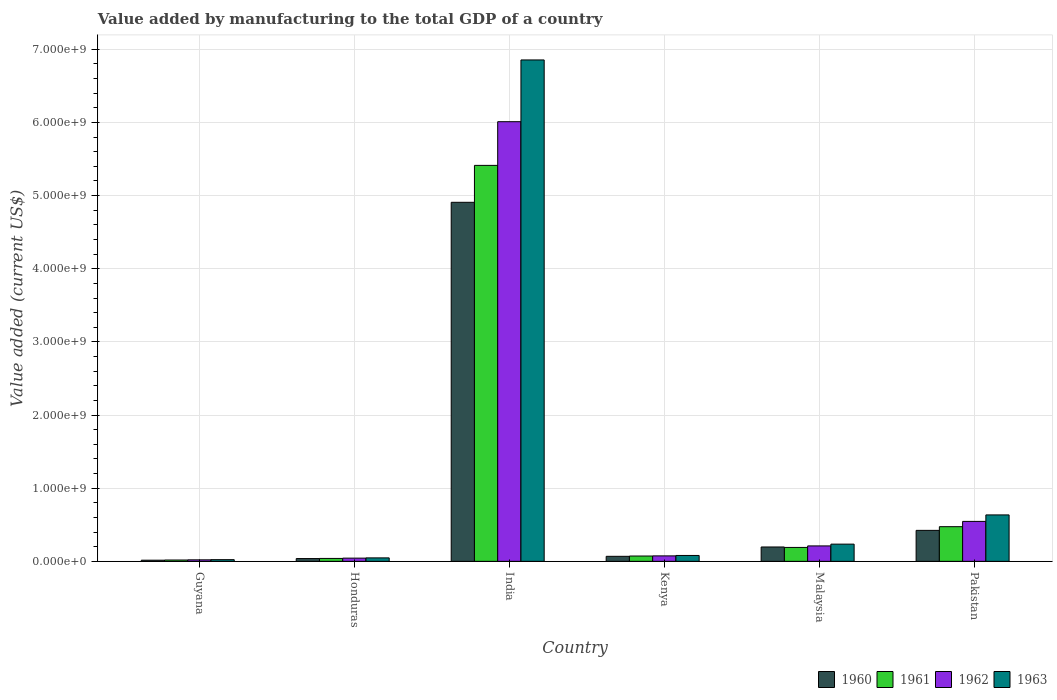How many groups of bars are there?
Offer a very short reply. 6. Are the number of bars per tick equal to the number of legend labels?
Make the answer very short. Yes. How many bars are there on the 1st tick from the right?
Your answer should be compact. 4. What is the label of the 1st group of bars from the left?
Make the answer very short. Guyana. In how many cases, is the number of bars for a given country not equal to the number of legend labels?
Provide a succinct answer. 0. What is the value added by manufacturing to the total GDP in 1960 in India?
Offer a terse response. 4.91e+09. Across all countries, what is the maximum value added by manufacturing to the total GDP in 1961?
Offer a very short reply. 5.41e+09. Across all countries, what is the minimum value added by manufacturing to the total GDP in 1963?
Offer a very short reply. 2.32e+07. In which country was the value added by manufacturing to the total GDP in 1961 minimum?
Your answer should be very brief. Guyana. What is the total value added by manufacturing to the total GDP in 1961 in the graph?
Your response must be concise. 6.21e+09. What is the difference between the value added by manufacturing to the total GDP in 1961 in Honduras and that in Pakistan?
Keep it short and to the point. -4.34e+08. What is the difference between the value added by manufacturing to the total GDP in 1961 in Kenya and the value added by manufacturing to the total GDP in 1960 in Guyana?
Provide a succinct answer. 5.70e+07. What is the average value added by manufacturing to the total GDP in 1963 per country?
Your answer should be very brief. 1.31e+09. What is the difference between the value added by manufacturing to the total GDP of/in 1963 and value added by manufacturing to the total GDP of/in 1961 in Kenya?
Offer a terse response. 7.70e+06. In how many countries, is the value added by manufacturing to the total GDP in 1961 greater than 4000000000 US$?
Provide a succinct answer. 1. What is the ratio of the value added by manufacturing to the total GDP in 1962 in India to that in Kenya?
Your response must be concise. 80.31. Is the value added by manufacturing to the total GDP in 1963 in Honduras less than that in Pakistan?
Ensure brevity in your answer.  Yes. Is the difference between the value added by manufacturing to the total GDP in 1963 in Guyana and Malaysia greater than the difference between the value added by manufacturing to the total GDP in 1961 in Guyana and Malaysia?
Make the answer very short. No. What is the difference between the highest and the second highest value added by manufacturing to the total GDP in 1960?
Offer a very short reply. 2.27e+08. What is the difference between the highest and the lowest value added by manufacturing to the total GDP in 1961?
Provide a short and direct response. 5.40e+09. What does the 1st bar from the left in Pakistan represents?
Offer a terse response. 1960. What does the 2nd bar from the right in Honduras represents?
Provide a succinct answer. 1962. How many bars are there?
Provide a short and direct response. 24. Are all the bars in the graph horizontal?
Offer a very short reply. No. How many legend labels are there?
Make the answer very short. 4. What is the title of the graph?
Give a very brief answer. Value added by manufacturing to the total GDP of a country. Does "1981" appear as one of the legend labels in the graph?
Ensure brevity in your answer.  No. What is the label or title of the X-axis?
Ensure brevity in your answer.  Country. What is the label or title of the Y-axis?
Your response must be concise. Value added (current US$). What is the Value added (current US$) of 1960 in Guyana?
Keep it short and to the point. 1.59e+07. What is the Value added (current US$) of 1961 in Guyana?
Your response must be concise. 1.84e+07. What is the Value added (current US$) of 1962 in Guyana?
Keep it short and to the point. 2.08e+07. What is the Value added (current US$) in 1963 in Guyana?
Offer a terse response. 2.32e+07. What is the Value added (current US$) in 1960 in Honduras?
Give a very brief answer. 3.80e+07. What is the Value added (current US$) of 1961 in Honduras?
Keep it short and to the point. 4.00e+07. What is the Value added (current US$) of 1962 in Honduras?
Your answer should be very brief. 4.41e+07. What is the Value added (current US$) in 1963 in Honduras?
Your answer should be very brief. 4.76e+07. What is the Value added (current US$) of 1960 in India?
Provide a succinct answer. 4.91e+09. What is the Value added (current US$) in 1961 in India?
Provide a succinct answer. 5.41e+09. What is the Value added (current US$) in 1962 in India?
Give a very brief answer. 6.01e+09. What is the Value added (current US$) in 1963 in India?
Make the answer very short. 6.85e+09. What is the Value added (current US$) in 1960 in Kenya?
Your answer should be compact. 6.89e+07. What is the Value added (current US$) of 1961 in Kenya?
Make the answer very short. 7.28e+07. What is the Value added (current US$) of 1962 in Kenya?
Your answer should be compact. 7.48e+07. What is the Value added (current US$) of 1963 in Kenya?
Provide a short and direct response. 8.05e+07. What is the Value added (current US$) in 1960 in Malaysia?
Make the answer very short. 1.97e+08. What is the Value added (current US$) of 1961 in Malaysia?
Offer a very short reply. 1.90e+08. What is the Value added (current US$) in 1962 in Malaysia?
Offer a very short reply. 2.11e+08. What is the Value added (current US$) of 1963 in Malaysia?
Provide a short and direct response. 2.36e+08. What is the Value added (current US$) of 1960 in Pakistan?
Make the answer very short. 4.24e+08. What is the Value added (current US$) of 1961 in Pakistan?
Your answer should be very brief. 4.74e+08. What is the Value added (current US$) in 1962 in Pakistan?
Offer a very short reply. 5.46e+08. What is the Value added (current US$) in 1963 in Pakistan?
Your response must be concise. 6.35e+08. Across all countries, what is the maximum Value added (current US$) of 1960?
Provide a short and direct response. 4.91e+09. Across all countries, what is the maximum Value added (current US$) of 1961?
Make the answer very short. 5.41e+09. Across all countries, what is the maximum Value added (current US$) in 1962?
Your answer should be compact. 6.01e+09. Across all countries, what is the maximum Value added (current US$) in 1963?
Provide a succinct answer. 6.85e+09. Across all countries, what is the minimum Value added (current US$) of 1960?
Provide a short and direct response. 1.59e+07. Across all countries, what is the minimum Value added (current US$) of 1961?
Your answer should be compact. 1.84e+07. Across all countries, what is the minimum Value added (current US$) of 1962?
Offer a very short reply. 2.08e+07. Across all countries, what is the minimum Value added (current US$) of 1963?
Keep it short and to the point. 2.32e+07. What is the total Value added (current US$) of 1960 in the graph?
Your response must be concise. 5.65e+09. What is the total Value added (current US$) of 1961 in the graph?
Provide a succinct answer. 6.21e+09. What is the total Value added (current US$) of 1962 in the graph?
Offer a very short reply. 6.91e+09. What is the total Value added (current US$) of 1963 in the graph?
Offer a very short reply. 7.88e+09. What is the difference between the Value added (current US$) of 1960 in Guyana and that in Honduras?
Give a very brief answer. -2.22e+07. What is the difference between the Value added (current US$) of 1961 in Guyana and that in Honduras?
Provide a succinct answer. -2.17e+07. What is the difference between the Value added (current US$) in 1962 in Guyana and that in Honduras?
Provide a short and direct response. -2.33e+07. What is the difference between the Value added (current US$) of 1963 in Guyana and that in Honduras?
Give a very brief answer. -2.44e+07. What is the difference between the Value added (current US$) in 1960 in Guyana and that in India?
Provide a succinct answer. -4.89e+09. What is the difference between the Value added (current US$) of 1961 in Guyana and that in India?
Your response must be concise. -5.40e+09. What is the difference between the Value added (current US$) of 1962 in Guyana and that in India?
Your answer should be compact. -5.99e+09. What is the difference between the Value added (current US$) in 1963 in Guyana and that in India?
Your answer should be very brief. -6.83e+09. What is the difference between the Value added (current US$) of 1960 in Guyana and that in Kenya?
Give a very brief answer. -5.30e+07. What is the difference between the Value added (current US$) in 1961 in Guyana and that in Kenya?
Your response must be concise. -5.45e+07. What is the difference between the Value added (current US$) of 1962 in Guyana and that in Kenya?
Provide a short and direct response. -5.41e+07. What is the difference between the Value added (current US$) in 1963 in Guyana and that in Kenya?
Give a very brief answer. -5.74e+07. What is the difference between the Value added (current US$) of 1960 in Guyana and that in Malaysia?
Your answer should be very brief. -1.81e+08. What is the difference between the Value added (current US$) of 1961 in Guyana and that in Malaysia?
Your answer should be compact. -1.72e+08. What is the difference between the Value added (current US$) of 1962 in Guyana and that in Malaysia?
Provide a succinct answer. -1.90e+08. What is the difference between the Value added (current US$) of 1963 in Guyana and that in Malaysia?
Give a very brief answer. -2.12e+08. What is the difference between the Value added (current US$) of 1960 in Guyana and that in Pakistan?
Provide a succinct answer. -4.08e+08. What is the difference between the Value added (current US$) of 1961 in Guyana and that in Pakistan?
Ensure brevity in your answer.  -4.56e+08. What is the difference between the Value added (current US$) in 1962 in Guyana and that in Pakistan?
Your answer should be compact. -5.26e+08. What is the difference between the Value added (current US$) of 1963 in Guyana and that in Pakistan?
Ensure brevity in your answer.  -6.12e+08. What is the difference between the Value added (current US$) in 1960 in Honduras and that in India?
Your answer should be compact. -4.87e+09. What is the difference between the Value added (current US$) in 1961 in Honduras and that in India?
Give a very brief answer. -5.37e+09. What is the difference between the Value added (current US$) of 1962 in Honduras and that in India?
Offer a very short reply. -5.97e+09. What is the difference between the Value added (current US$) of 1963 in Honduras and that in India?
Provide a short and direct response. -6.81e+09. What is the difference between the Value added (current US$) of 1960 in Honduras and that in Kenya?
Ensure brevity in your answer.  -3.09e+07. What is the difference between the Value added (current US$) of 1961 in Honduras and that in Kenya?
Make the answer very short. -3.28e+07. What is the difference between the Value added (current US$) of 1962 in Honduras and that in Kenya?
Give a very brief answer. -3.07e+07. What is the difference between the Value added (current US$) in 1963 in Honduras and that in Kenya?
Provide a succinct answer. -3.30e+07. What is the difference between the Value added (current US$) in 1960 in Honduras and that in Malaysia?
Offer a very short reply. -1.59e+08. What is the difference between the Value added (current US$) in 1961 in Honduras and that in Malaysia?
Make the answer very short. -1.50e+08. What is the difference between the Value added (current US$) in 1962 in Honduras and that in Malaysia?
Provide a short and direct response. -1.67e+08. What is the difference between the Value added (current US$) of 1963 in Honduras and that in Malaysia?
Offer a very short reply. -1.88e+08. What is the difference between the Value added (current US$) in 1960 in Honduras and that in Pakistan?
Offer a very short reply. -3.86e+08. What is the difference between the Value added (current US$) of 1961 in Honduras and that in Pakistan?
Make the answer very short. -4.34e+08. What is the difference between the Value added (current US$) in 1962 in Honduras and that in Pakistan?
Offer a terse response. -5.02e+08. What is the difference between the Value added (current US$) of 1963 in Honduras and that in Pakistan?
Ensure brevity in your answer.  -5.87e+08. What is the difference between the Value added (current US$) of 1960 in India and that in Kenya?
Offer a terse response. 4.84e+09. What is the difference between the Value added (current US$) of 1961 in India and that in Kenya?
Your answer should be very brief. 5.34e+09. What is the difference between the Value added (current US$) of 1962 in India and that in Kenya?
Provide a succinct answer. 5.94e+09. What is the difference between the Value added (current US$) of 1963 in India and that in Kenya?
Your answer should be compact. 6.77e+09. What is the difference between the Value added (current US$) in 1960 in India and that in Malaysia?
Provide a short and direct response. 4.71e+09. What is the difference between the Value added (current US$) of 1961 in India and that in Malaysia?
Your answer should be very brief. 5.22e+09. What is the difference between the Value added (current US$) of 1962 in India and that in Malaysia?
Provide a succinct answer. 5.80e+09. What is the difference between the Value added (current US$) of 1963 in India and that in Malaysia?
Provide a succinct answer. 6.62e+09. What is the difference between the Value added (current US$) of 1960 in India and that in Pakistan?
Your answer should be very brief. 4.48e+09. What is the difference between the Value added (current US$) in 1961 in India and that in Pakistan?
Make the answer very short. 4.94e+09. What is the difference between the Value added (current US$) in 1962 in India and that in Pakistan?
Keep it short and to the point. 5.46e+09. What is the difference between the Value added (current US$) in 1963 in India and that in Pakistan?
Your answer should be compact. 6.22e+09. What is the difference between the Value added (current US$) in 1960 in Kenya and that in Malaysia?
Provide a short and direct response. -1.28e+08. What is the difference between the Value added (current US$) in 1961 in Kenya and that in Malaysia?
Ensure brevity in your answer.  -1.18e+08. What is the difference between the Value added (current US$) in 1962 in Kenya and that in Malaysia?
Give a very brief answer. -1.36e+08. What is the difference between the Value added (current US$) of 1963 in Kenya and that in Malaysia?
Ensure brevity in your answer.  -1.55e+08. What is the difference between the Value added (current US$) of 1960 in Kenya and that in Pakistan?
Your answer should be very brief. -3.55e+08. What is the difference between the Value added (current US$) of 1961 in Kenya and that in Pakistan?
Offer a very short reply. -4.01e+08. What is the difference between the Value added (current US$) in 1962 in Kenya and that in Pakistan?
Give a very brief answer. -4.72e+08. What is the difference between the Value added (current US$) of 1963 in Kenya and that in Pakistan?
Provide a short and direct response. -5.54e+08. What is the difference between the Value added (current US$) of 1960 in Malaysia and that in Pakistan?
Ensure brevity in your answer.  -2.27e+08. What is the difference between the Value added (current US$) of 1961 in Malaysia and that in Pakistan?
Keep it short and to the point. -2.84e+08. What is the difference between the Value added (current US$) in 1962 in Malaysia and that in Pakistan?
Your answer should be compact. -3.35e+08. What is the difference between the Value added (current US$) of 1963 in Malaysia and that in Pakistan?
Keep it short and to the point. -3.99e+08. What is the difference between the Value added (current US$) in 1960 in Guyana and the Value added (current US$) in 1961 in Honduras?
Offer a very short reply. -2.42e+07. What is the difference between the Value added (current US$) in 1960 in Guyana and the Value added (current US$) in 1962 in Honduras?
Your answer should be very brief. -2.82e+07. What is the difference between the Value added (current US$) in 1960 in Guyana and the Value added (current US$) in 1963 in Honduras?
Your answer should be compact. -3.17e+07. What is the difference between the Value added (current US$) of 1961 in Guyana and the Value added (current US$) of 1962 in Honduras?
Give a very brief answer. -2.57e+07. What is the difference between the Value added (current US$) of 1961 in Guyana and the Value added (current US$) of 1963 in Honduras?
Ensure brevity in your answer.  -2.92e+07. What is the difference between the Value added (current US$) of 1962 in Guyana and the Value added (current US$) of 1963 in Honduras?
Give a very brief answer. -2.68e+07. What is the difference between the Value added (current US$) of 1960 in Guyana and the Value added (current US$) of 1961 in India?
Offer a terse response. -5.40e+09. What is the difference between the Value added (current US$) of 1960 in Guyana and the Value added (current US$) of 1962 in India?
Give a very brief answer. -5.99e+09. What is the difference between the Value added (current US$) of 1960 in Guyana and the Value added (current US$) of 1963 in India?
Your answer should be very brief. -6.84e+09. What is the difference between the Value added (current US$) of 1961 in Guyana and the Value added (current US$) of 1962 in India?
Offer a terse response. -5.99e+09. What is the difference between the Value added (current US$) of 1961 in Guyana and the Value added (current US$) of 1963 in India?
Give a very brief answer. -6.84e+09. What is the difference between the Value added (current US$) of 1962 in Guyana and the Value added (current US$) of 1963 in India?
Ensure brevity in your answer.  -6.83e+09. What is the difference between the Value added (current US$) in 1960 in Guyana and the Value added (current US$) in 1961 in Kenya?
Your response must be concise. -5.70e+07. What is the difference between the Value added (current US$) of 1960 in Guyana and the Value added (current US$) of 1962 in Kenya?
Your answer should be very brief. -5.90e+07. What is the difference between the Value added (current US$) of 1960 in Guyana and the Value added (current US$) of 1963 in Kenya?
Your answer should be compact. -6.47e+07. What is the difference between the Value added (current US$) in 1961 in Guyana and the Value added (current US$) in 1962 in Kenya?
Your answer should be very brief. -5.65e+07. What is the difference between the Value added (current US$) in 1961 in Guyana and the Value added (current US$) in 1963 in Kenya?
Give a very brief answer. -6.22e+07. What is the difference between the Value added (current US$) of 1962 in Guyana and the Value added (current US$) of 1963 in Kenya?
Offer a terse response. -5.98e+07. What is the difference between the Value added (current US$) in 1960 in Guyana and the Value added (current US$) in 1961 in Malaysia?
Your answer should be very brief. -1.75e+08. What is the difference between the Value added (current US$) in 1960 in Guyana and the Value added (current US$) in 1962 in Malaysia?
Your answer should be very brief. -1.95e+08. What is the difference between the Value added (current US$) in 1960 in Guyana and the Value added (current US$) in 1963 in Malaysia?
Your answer should be compact. -2.20e+08. What is the difference between the Value added (current US$) of 1961 in Guyana and the Value added (current US$) of 1962 in Malaysia?
Provide a short and direct response. -1.93e+08. What is the difference between the Value added (current US$) of 1961 in Guyana and the Value added (current US$) of 1963 in Malaysia?
Keep it short and to the point. -2.17e+08. What is the difference between the Value added (current US$) of 1962 in Guyana and the Value added (current US$) of 1963 in Malaysia?
Ensure brevity in your answer.  -2.15e+08. What is the difference between the Value added (current US$) in 1960 in Guyana and the Value added (current US$) in 1961 in Pakistan?
Keep it short and to the point. -4.58e+08. What is the difference between the Value added (current US$) in 1960 in Guyana and the Value added (current US$) in 1962 in Pakistan?
Make the answer very short. -5.31e+08. What is the difference between the Value added (current US$) of 1960 in Guyana and the Value added (current US$) of 1963 in Pakistan?
Keep it short and to the point. -6.19e+08. What is the difference between the Value added (current US$) of 1961 in Guyana and the Value added (current US$) of 1962 in Pakistan?
Your response must be concise. -5.28e+08. What is the difference between the Value added (current US$) in 1961 in Guyana and the Value added (current US$) in 1963 in Pakistan?
Offer a very short reply. -6.17e+08. What is the difference between the Value added (current US$) in 1962 in Guyana and the Value added (current US$) in 1963 in Pakistan?
Make the answer very short. -6.14e+08. What is the difference between the Value added (current US$) of 1960 in Honduras and the Value added (current US$) of 1961 in India?
Make the answer very short. -5.38e+09. What is the difference between the Value added (current US$) in 1960 in Honduras and the Value added (current US$) in 1962 in India?
Offer a very short reply. -5.97e+09. What is the difference between the Value added (current US$) in 1960 in Honduras and the Value added (current US$) in 1963 in India?
Your answer should be very brief. -6.82e+09. What is the difference between the Value added (current US$) of 1961 in Honduras and the Value added (current US$) of 1962 in India?
Your response must be concise. -5.97e+09. What is the difference between the Value added (current US$) in 1961 in Honduras and the Value added (current US$) in 1963 in India?
Make the answer very short. -6.81e+09. What is the difference between the Value added (current US$) of 1962 in Honduras and the Value added (current US$) of 1963 in India?
Provide a succinct answer. -6.81e+09. What is the difference between the Value added (current US$) in 1960 in Honduras and the Value added (current US$) in 1961 in Kenya?
Provide a succinct answer. -3.48e+07. What is the difference between the Value added (current US$) in 1960 in Honduras and the Value added (current US$) in 1962 in Kenya?
Offer a very short reply. -3.68e+07. What is the difference between the Value added (current US$) in 1960 in Honduras and the Value added (current US$) in 1963 in Kenya?
Your answer should be compact. -4.25e+07. What is the difference between the Value added (current US$) in 1961 in Honduras and the Value added (current US$) in 1962 in Kenya?
Keep it short and to the point. -3.48e+07. What is the difference between the Value added (current US$) of 1961 in Honduras and the Value added (current US$) of 1963 in Kenya?
Your response must be concise. -4.05e+07. What is the difference between the Value added (current US$) in 1962 in Honduras and the Value added (current US$) in 1963 in Kenya?
Provide a succinct answer. -3.64e+07. What is the difference between the Value added (current US$) of 1960 in Honduras and the Value added (current US$) of 1961 in Malaysia?
Your response must be concise. -1.52e+08. What is the difference between the Value added (current US$) of 1960 in Honduras and the Value added (current US$) of 1962 in Malaysia?
Your response must be concise. -1.73e+08. What is the difference between the Value added (current US$) of 1960 in Honduras and the Value added (current US$) of 1963 in Malaysia?
Keep it short and to the point. -1.97e+08. What is the difference between the Value added (current US$) in 1961 in Honduras and the Value added (current US$) in 1962 in Malaysia?
Ensure brevity in your answer.  -1.71e+08. What is the difference between the Value added (current US$) in 1961 in Honduras and the Value added (current US$) in 1963 in Malaysia?
Offer a terse response. -1.95e+08. What is the difference between the Value added (current US$) in 1962 in Honduras and the Value added (current US$) in 1963 in Malaysia?
Offer a very short reply. -1.91e+08. What is the difference between the Value added (current US$) of 1960 in Honduras and the Value added (current US$) of 1961 in Pakistan?
Keep it short and to the point. -4.36e+08. What is the difference between the Value added (current US$) in 1960 in Honduras and the Value added (current US$) in 1962 in Pakistan?
Your response must be concise. -5.08e+08. What is the difference between the Value added (current US$) in 1960 in Honduras and the Value added (current US$) in 1963 in Pakistan?
Your answer should be very brief. -5.97e+08. What is the difference between the Value added (current US$) of 1961 in Honduras and the Value added (current US$) of 1962 in Pakistan?
Your response must be concise. -5.06e+08. What is the difference between the Value added (current US$) in 1961 in Honduras and the Value added (current US$) in 1963 in Pakistan?
Ensure brevity in your answer.  -5.95e+08. What is the difference between the Value added (current US$) in 1962 in Honduras and the Value added (current US$) in 1963 in Pakistan?
Provide a succinct answer. -5.91e+08. What is the difference between the Value added (current US$) in 1960 in India and the Value added (current US$) in 1961 in Kenya?
Offer a very short reply. 4.84e+09. What is the difference between the Value added (current US$) in 1960 in India and the Value added (current US$) in 1962 in Kenya?
Provide a short and direct response. 4.83e+09. What is the difference between the Value added (current US$) of 1960 in India and the Value added (current US$) of 1963 in Kenya?
Give a very brief answer. 4.83e+09. What is the difference between the Value added (current US$) of 1961 in India and the Value added (current US$) of 1962 in Kenya?
Make the answer very short. 5.34e+09. What is the difference between the Value added (current US$) in 1961 in India and the Value added (current US$) in 1963 in Kenya?
Offer a very short reply. 5.33e+09. What is the difference between the Value added (current US$) of 1962 in India and the Value added (current US$) of 1963 in Kenya?
Ensure brevity in your answer.  5.93e+09. What is the difference between the Value added (current US$) of 1960 in India and the Value added (current US$) of 1961 in Malaysia?
Ensure brevity in your answer.  4.72e+09. What is the difference between the Value added (current US$) of 1960 in India and the Value added (current US$) of 1962 in Malaysia?
Keep it short and to the point. 4.70e+09. What is the difference between the Value added (current US$) of 1960 in India and the Value added (current US$) of 1963 in Malaysia?
Give a very brief answer. 4.67e+09. What is the difference between the Value added (current US$) in 1961 in India and the Value added (current US$) in 1962 in Malaysia?
Provide a succinct answer. 5.20e+09. What is the difference between the Value added (current US$) in 1961 in India and the Value added (current US$) in 1963 in Malaysia?
Make the answer very short. 5.18e+09. What is the difference between the Value added (current US$) of 1962 in India and the Value added (current US$) of 1963 in Malaysia?
Give a very brief answer. 5.78e+09. What is the difference between the Value added (current US$) in 1960 in India and the Value added (current US$) in 1961 in Pakistan?
Your answer should be compact. 4.43e+09. What is the difference between the Value added (current US$) in 1960 in India and the Value added (current US$) in 1962 in Pakistan?
Give a very brief answer. 4.36e+09. What is the difference between the Value added (current US$) of 1960 in India and the Value added (current US$) of 1963 in Pakistan?
Keep it short and to the point. 4.27e+09. What is the difference between the Value added (current US$) of 1961 in India and the Value added (current US$) of 1962 in Pakistan?
Your answer should be very brief. 4.87e+09. What is the difference between the Value added (current US$) of 1961 in India and the Value added (current US$) of 1963 in Pakistan?
Your answer should be very brief. 4.78e+09. What is the difference between the Value added (current US$) of 1962 in India and the Value added (current US$) of 1963 in Pakistan?
Your answer should be very brief. 5.38e+09. What is the difference between the Value added (current US$) in 1960 in Kenya and the Value added (current US$) in 1961 in Malaysia?
Your answer should be compact. -1.21e+08. What is the difference between the Value added (current US$) of 1960 in Kenya and the Value added (current US$) of 1962 in Malaysia?
Your answer should be compact. -1.42e+08. What is the difference between the Value added (current US$) in 1960 in Kenya and the Value added (current US$) in 1963 in Malaysia?
Your answer should be very brief. -1.67e+08. What is the difference between the Value added (current US$) of 1961 in Kenya and the Value added (current US$) of 1962 in Malaysia?
Your response must be concise. -1.38e+08. What is the difference between the Value added (current US$) in 1961 in Kenya and the Value added (current US$) in 1963 in Malaysia?
Give a very brief answer. -1.63e+08. What is the difference between the Value added (current US$) in 1962 in Kenya and the Value added (current US$) in 1963 in Malaysia?
Offer a terse response. -1.61e+08. What is the difference between the Value added (current US$) in 1960 in Kenya and the Value added (current US$) in 1961 in Pakistan?
Your response must be concise. -4.05e+08. What is the difference between the Value added (current US$) of 1960 in Kenya and the Value added (current US$) of 1962 in Pakistan?
Offer a very short reply. -4.78e+08. What is the difference between the Value added (current US$) of 1960 in Kenya and the Value added (current US$) of 1963 in Pakistan?
Offer a very short reply. -5.66e+08. What is the difference between the Value added (current US$) of 1961 in Kenya and the Value added (current US$) of 1962 in Pakistan?
Your answer should be compact. -4.74e+08. What is the difference between the Value added (current US$) in 1961 in Kenya and the Value added (current US$) in 1963 in Pakistan?
Keep it short and to the point. -5.62e+08. What is the difference between the Value added (current US$) of 1962 in Kenya and the Value added (current US$) of 1963 in Pakistan?
Keep it short and to the point. -5.60e+08. What is the difference between the Value added (current US$) of 1960 in Malaysia and the Value added (current US$) of 1961 in Pakistan?
Your response must be concise. -2.78e+08. What is the difference between the Value added (current US$) in 1960 in Malaysia and the Value added (current US$) in 1962 in Pakistan?
Your answer should be compact. -3.50e+08. What is the difference between the Value added (current US$) of 1960 in Malaysia and the Value added (current US$) of 1963 in Pakistan?
Offer a very short reply. -4.38e+08. What is the difference between the Value added (current US$) in 1961 in Malaysia and the Value added (current US$) in 1962 in Pakistan?
Make the answer very short. -3.56e+08. What is the difference between the Value added (current US$) of 1961 in Malaysia and the Value added (current US$) of 1963 in Pakistan?
Your answer should be very brief. -4.45e+08. What is the difference between the Value added (current US$) in 1962 in Malaysia and the Value added (current US$) in 1963 in Pakistan?
Provide a short and direct response. -4.24e+08. What is the average Value added (current US$) of 1960 per country?
Your answer should be compact. 9.42e+08. What is the average Value added (current US$) in 1961 per country?
Your answer should be very brief. 1.03e+09. What is the average Value added (current US$) of 1962 per country?
Your answer should be compact. 1.15e+09. What is the average Value added (current US$) of 1963 per country?
Your answer should be very brief. 1.31e+09. What is the difference between the Value added (current US$) in 1960 and Value added (current US$) in 1961 in Guyana?
Your answer should be very brief. -2.51e+06. What is the difference between the Value added (current US$) in 1960 and Value added (current US$) in 1962 in Guyana?
Your response must be concise. -4.90e+06. What is the difference between the Value added (current US$) in 1960 and Value added (current US$) in 1963 in Guyana?
Provide a succinct answer. -7.29e+06. What is the difference between the Value added (current US$) of 1961 and Value added (current US$) of 1962 in Guyana?
Your response must be concise. -2.39e+06. What is the difference between the Value added (current US$) in 1961 and Value added (current US$) in 1963 in Guyana?
Your answer should be very brief. -4.78e+06. What is the difference between the Value added (current US$) in 1962 and Value added (current US$) in 1963 in Guyana?
Provide a short and direct response. -2.39e+06. What is the difference between the Value added (current US$) of 1960 and Value added (current US$) of 1962 in Honduras?
Offer a terse response. -6.05e+06. What is the difference between the Value added (current US$) of 1960 and Value added (current US$) of 1963 in Honduras?
Make the answer very short. -9.50e+06. What is the difference between the Value added (current US$) of 1961 and Value added (current US$) of 1962 in Honduras?
Offer a very short reply. -4.05e+06. What is the difference between the Value added (current US$) in 1961 and Value added (current US$) in 1963 in Honduras?
Your answer should be very brief. -7.50e+06. What is the difference between the Value added (current US$) in 1962 and Value added (current US$) in 1963 in Honduras?
Provide a succinct answer. -3.45e+06. What is the difference between the Value added (current US$) of 1960 and Value added (current US$) of 1961 in India?
Offer a very short reply. -5.05e+08. What is the difference between the Value added (current US$) in 1960 and Value added (current US$) in 1962 in India?
Keep it short and to the point. -1.10e+09. What is the difference between the Value added (current US$) in 1960 and Value added (current US$) in 1963 in India?
Ensure brevity in your answer.  -1.95e+09. What is the difference between the Value added (current US$) in 1961 and Value added (current US$) in 1962 in India?
Give a very brief answer. -5.97e+08. What is the difference between the Value added (current US$) of 1961 and Value added (current US$) of 1963 in India?
Provide a short and direct response. -1.44e+09. What is the difference between the Value added (current US$) in 1962 and Value added (current US$) in 1963 in India?
Your answer should be very brief. -8.44e+08. What is the difference between the Value added (current US$) of 1960 and Value added (current US$) of 1961 in Kenya?
Your response must be concise. -3.93e+06. What is the difference between the Value added (current US$) of 1960 and Value added (current US$) of 1962 in Kenya?
Your answer should be very brief. -5.94e+06. What is the difference between the Value added (current US$) of 1960 and Value added (current US$) of 1963 in Kenya?
Provide a short and direct response. -1.16e+07. What is the difference between the Value added (current US$) in 1961 and Value added (current US$) in 1962 in Kenya?
Your answer should be very brief. -2.00e+06. What is the difference between the Value added (current US$) in 1961 and Value added (current US$) in 1963 in Kenya?
Provide a succinct answer. -7.70e+06. What is the difference between the Value added (current US$) of 1962 and Value added (current US$) of 1963 in Kenya?
Your answer should be compact. -5.70e+06. What is the difference between the Value added (current US$) of 1960 and Value added (current US$) of 1961 in Malaysia?
Provide a short and direct response. 6.25e+06. What is the difference between the Value added (current US$) in 1960 and Value added (current US$) in 1962 in Malaysia?
Provide a short and direct response. -1.46e+07. What is the difference between the Value added (current US$) of 1960 and Value added (current US$) of 1963 in Malaysia?
Make the answer very short. -3.89e+07. What is the difference between the Value added (current US$) in 1961 and Value added (current US$) in 1962 in Malaysia?
Give a very brief answer. -2.08e+07. What is the difference between the Value added (current US$) in 1961 and Value added (current US$) in 1963 in Malaysia?
Give a very brief answer. -4.52e+07. What is the difference between the Value added (current US$) of 1962 and Value added (current US$) of 1963 in Malaysia?
Make the answer very short. -2.43e+07. What is the difference between the Value added (current US$) in 1960 and Value added (current US$) in 1961 in Pakistan?
Offer a terse response. -5.04e+07. What is the difference between the Value added (current US$) of 1960 and Value added (current US$) of 1962 in Pakistan?
Ensure brevity in your answer.  -1.23e+08. What is the difference between the Value added (current US$) of 1960 and Value added (current US$) of 1963 in Pakistan?
Your answer should be very brief. -2.11e+08. What is the difference between the Value added (current US$) of 1961 and Value added (current US$) of 1962 in Pakistan?
Make the answer very short. -7.22e+07. What is the difference between the Value added (current US$) of 1961 and Value added (current US$) of 1963 in Pakistan?
Your response must be concise. -1.61e+08. What is the difference between the Value added (current US$) in 1962 and Value added (current US$) in 1963 in Pakistan?
Offer a very short reply. -8.86e+07. What is the ratio of the Value added (current US$) of 1960 in Guyana to that in Honduras?
Keep it short and to the point. 0.42. What is the ratio of the Value added (current US$) of 1961 in Guyana to that in Honduras?
Give a very brief answer. 0.46. What is the ratio of the Value added (current US$) in 1962 in Guyana to that in Honduras?
Keep it short and to the point. 0.47. What is the ratio of the Value added (current US$) of 1963 in Guyana to that in Honduras?
Give a very brief answer. 0.49. What is the ratio of the Value added (current US$) of 1960 in Guyana to that in India?
Offer a very short reply. 0. What is the ratio of the Value added (current US$) in 1961 in Guyana to that in India?
Your response must be concise. 0. What is the ratio of the Value added (current US$) of 1962 in Guyana to that in India?
Your response must be concise. 0. What is the ratio of the Value added (current US$) of 1963 in Guyana to that in India?
Keep it short and to the point. 0. What is the ratio of the Value added (current US$) in 1960 in Guyana to that in Kenya?
Provide a short and direct response. 0.23. What is the ratio of the Value added (current US$) in 1961 in Guyana to that in Kenya?
Your answer should be very brief. 0.25. What is the ratio of the Value added (current US$) in 1962 in Guyana to that in Kenya?
Provide a succinct answer. 0.28. What is the ratio of the Value added (current US$) of 1963 in Guyana to that in Kenya?
Offer a terse response. 0.29. What is the ratio of the Value added (current US$) of 1960 in Guyana to that in Malaysia?
Provide a succinct answer. 0.08. What is the ratio of the Value added (current US$) in 1961 in Guyana to that in Malaysia?
Your answer should be compact. 0.1. What is the ratio of the Value added (current US$) in 1962 in Guyana to that in Malaysia?
Provide a succinct answer. 0.1. What is the ratio of the Value added (current US$) of 1963 in Guyana to that in Malaysia?
Offer a very short reply. 0.1. What is the ratio of the Value added (current US$) of 1960 in Guyana to that in Pakistan?
Provide a succinct answer. 0.04. What is the ratio of the Value added (current US$) of 1961 in Guyana to that in Pakistan?
Offer a terse response. 0.04. What is the ratio of the Value added (current US$) of 1962 in Guyana to that in Pakistan?
Provide a succinct answer. 0.04. What is the ratio of the Value added (current US$) in 1963 in Guyana to that in Pakistan?
Provide a succinct answer. 0.04. What is the ratio of the Value added (current US$) of 1960 in Honduras to that in India?
Your answer should be compact. 0.01. What is the ratio of the Value added (current US$) in 1961 in Honduras to that in India?
Give a very brief answer. 0.01. What is the ratio of the Value added (current US$) in 1962 in Honduras to that in India?
Give a very brief answer. 0.01. What is the ratio of the Value added (current US$) in 1963 in Honduras to that in India?
Make the answer very short. 0.01. What is the ratio of the Value added (current US$) of 1960 in Honduras to that in Kenya?
Your answer should be very brief. 0.55. What is the ratio of the Value added (current US$) in 1961 in Honduras to that in Kenya?
Make the answer very short. 0.55. What is the ratio of the Value added (current US$) in 1962 in Honduras to that in Kenya?
Provide a short and direct response. 0.59. What is the ratio of the Value added (current US$) of 1963 in Honduras to that in Kenya?
Give a very brief answer. 0.59. What is the ratio of the Value added (current US$) of 1960 in Honduras to that in Malaysia?
Keep it short and to the point. 0.19. What is the ratio of the Value added (current US$) in 1961 in Honduras to that in Malaysia?
Offer a very short reply. 0.21. What is the ratio of the Value added (current US$) of 1962 in Honduras to that in Malaysia?
Your response must be concise. 0.21. What is the ratio of the Value added (current US$) in 1963 in Honduras to that in Malaysia?
Offer a very short reply. 0.2. What is the ratio of the Value added (current US$) of 1960 in Honduras to that in Pakistan?
Your answer should be compact. 0.09. What is the ratio of the Value added (current US$) in 1961 in Honduras to that in Pakistan?
Give a very brief answer. 0.08. What is the ratio of the Value added (current US$) in 1962 in Honduras to that in Pakistan?
Make the answer very short. 0.08. What is the ratio of the Value added (current US$) of 1963 in Honduras to that in Pakistan?
Offer a terse response. 0.07. What is the ratio of the Value added (current US$) of 1960 in India to that in Kenya?
Make the answer very short. 71.24. What is the ratio of the Value added (current US$) in 1961 in India to that in Kenya?
Ensure brevity in your answer.  74.32. What is the ratio of the Value added (current US$) in 1962 in India to that in Kenya?
Your answer should be very brief. 80.31. What is the ratio of the Value added (current US$) in 1963 in India to that in Kenya?
Offer a terse response. 85.11. What is the ratio of the Value added (current US$) in 1960 in India to that in Malaysia?
Provide a succinct answer. 24.96. What is the ratio of the Value added (current US$) of 1961 in India to that in Malaysia?
Offer a very short reply. 28.44. What is the ratio of the Value added (current US$) of 1962 in India to that in Malaysia?
Offer a terse response. 28.46. What is the ratio of the Value added (current US$) in 1963 in India to that in Malaysia?
Your answer should be compact. 29.1. What is the ratio of the Value added (current US$) in 1960 in India to that in Pakistan?
Your answer should be very brief. 11.58. What is the ratio of the Value added (current US$) in 1961 in India to that in Pakistan?
Offer a terse response. 11.42. What is the ratio of the Value added (current US$) of 1962 in India to that in Pakistan?
Provide a short and direct response. 11. What is the ratio of the Value added (current US$) of 1963 in India to that in Pakistan?
Offer a terse response. 10.79. What is the ratio of the Value added (current US$) in 1960 in Kenya to that in Malaysia?
Offer a very short reply. 0.35. What is the ratio of the Value added (current US$) in 1961 in Kenya to that in Malaysia?
Offer a terse response. 0.38. What is the ratio of the Value added (current US$) of 1962 in Kenya to that in Malaysia?
Your answer should be very brief. 0.35. What is the ratio of the Value added (current US$) in 1963 in Kenya to that in Malaysia?
Your answer should be very brief. 0.34. What is the ratio of the Value added (current US$) of 1960 in Kenya to that in Pakistan?
Your response must be concise. 0.16. What is the ratio of the Value added (current US$) in 1961 in Kenya to that in Pakistan?
Offer a very short reply. 0.15. What is the ratio of the Value added (current US$) in 1962 in Kenya to that in Pakistan?
Provide a short and direct response. 0.14. What is the ratio of the Value added (current US$) of 1963 in Kenya to that in Pakistan?
Offer a very short reply. 0.13. What is the ratio of the Value added (current US$) of 1960 in Malaysia to that in Pakistan?
Ensure brevity in your answer.  0.46. What is the ratio of the Value added (current US$) of 1961 in Malaysia to that in Pakistan?
Make the answer very short. 0.4. What is the ratio of the Value added (current US$) of 1962 in Malaysia to that in Pakistan?
Offer a very short reply. 0.39. What is the ratio of the Value added (current US$) of 1963 in Malaysia to that in Pakistan?
Offer a terse response. 0.37. What is the difference between the highest and the second highest Value added (current US$) in 1960?
Provide a short and direct response. 4.48e+09. What is the difference between the highest and the second highest Value added (current US$) in 1961?
Your answer should be compact. 4.94e+09. What is the difference between the highest and the second highest Value added (current US$) of 1962?
Give a very brief answer. 5.46e+09. What is the difference between the highest and the second highest Value added (current US$) of 1963?
Offer a terse response. 6.22e+09. What is the difference between the highest and the lowest Value added (current US$) of 1960?
Give a very brief answer. 4.89e+09. What is the difference between the highest and the lowest Value added (current US$) in 1961?
Keep it short and to the point. 5.40e+09. What is the difference between the highest and the lowest Value added (current US$) of 1962?
Offer a terse response. 5.99e+09. What is the difference between the highest and the lowest Value added (current US$) in 1963?
Provide a short and direct response. 6.83e+09. 